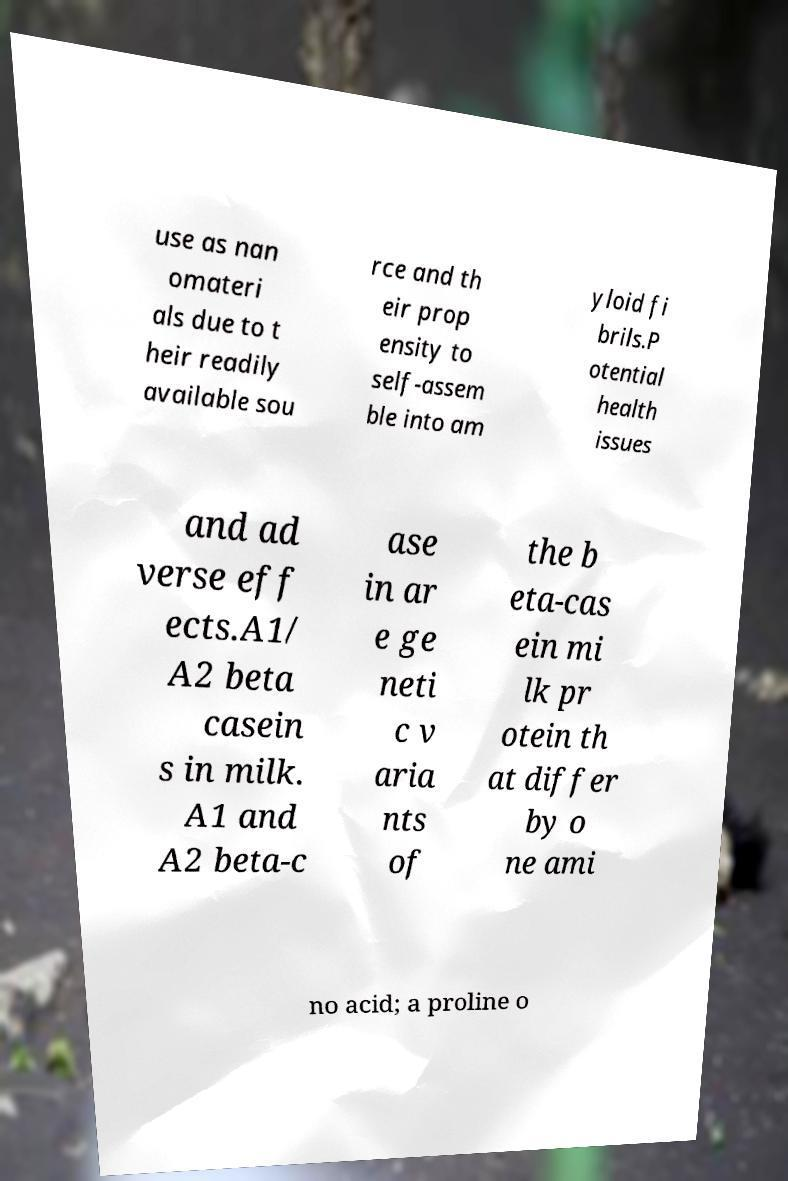I need the written content from this picture converted into text. Can you do that? use as nan omateri als due to t heir readily available sou rce and th eir prop ensity to self-assem ble into am yloid fi brils.P otential health issues and ad verse eff ects.A1/ A2 beta casein s in milk. A1 and A2 beta-c ase in ar e ge neti c v aria nts of the b eta-cas ein mi lk pr otein th at differ by o ne ami no acid; a proline o 